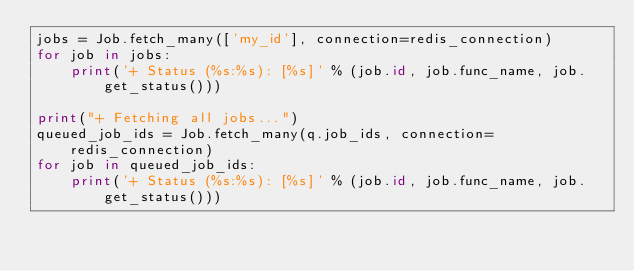<code> <loc_0><loc_0><loc_500><loc_500><_Python_>jobs = Job.fetch_many(['my_id'], connection=redis_connection)
for job in jobs:
    print('+ Status (%s:%s): [%s]' % (job.id, job.func_name, job.get_status()))

print("+ Fetching all jobs...")
queued_job_ids = Job.fetch_many(q.job_ids, connection=redis_connection)
for job in queued_job_ids:
    print('+ Status (%s:%s): [%s]' % (job.id, job.func_name, job.get_status()))

</code> 